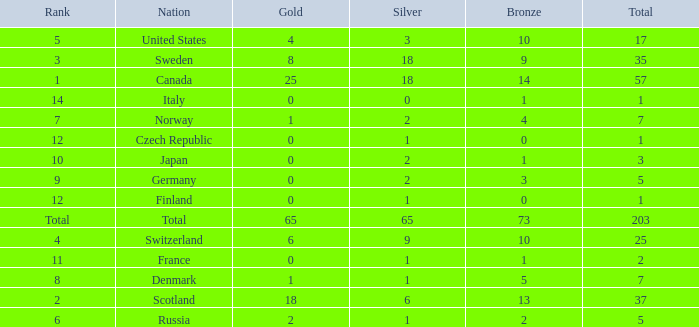What is the number of bronze medals when the total is greater than 1, more than 2 silver medals are won, and the rank is 2? 13.0. 